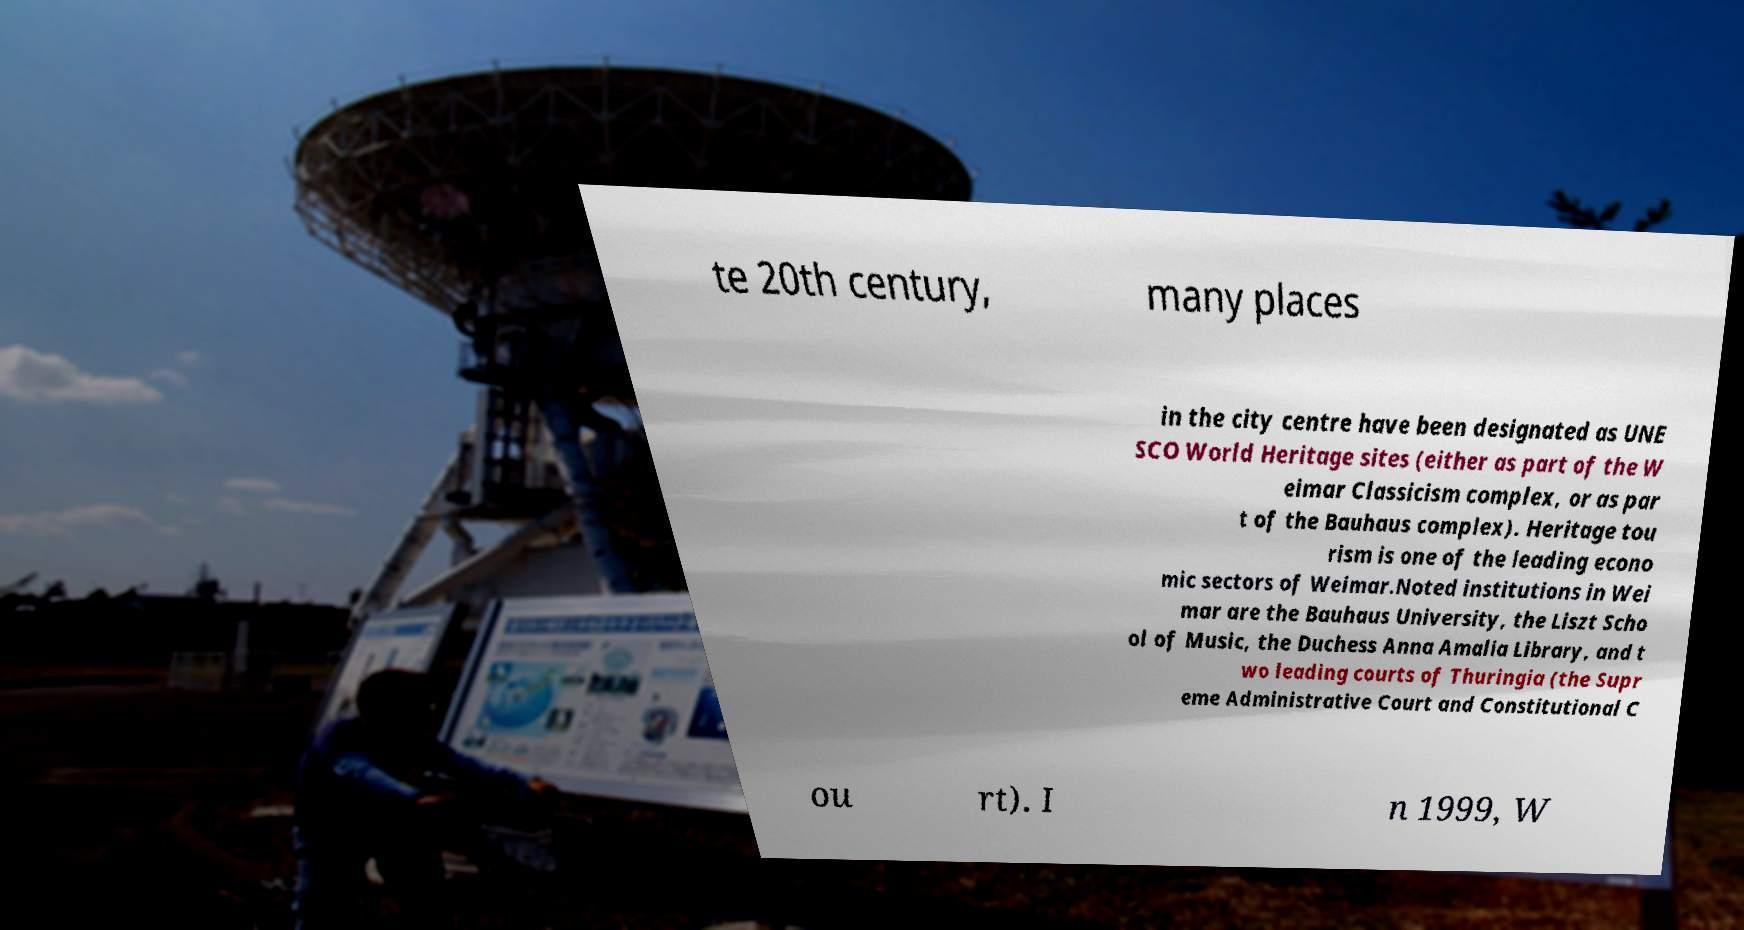Could you extract and type out the text from this image? te 20th century, many places in the city centre have been designated as UNE SCO World Heritage sites (either as part of the W eimar Classicism complex, or as par t of the Bauhaus complex). Heritage tou rism is one of the leading econo mic sectors of Weimar.Noted institutions in Wei mar are the Bauhaus University, the Liszt Scho ol of Music, the Duchess Anna Amalia Library, and t wo leading courts of Thuringia (the Supr eme Administrative Court and Constitutional C ou rt). I n 1999, W 